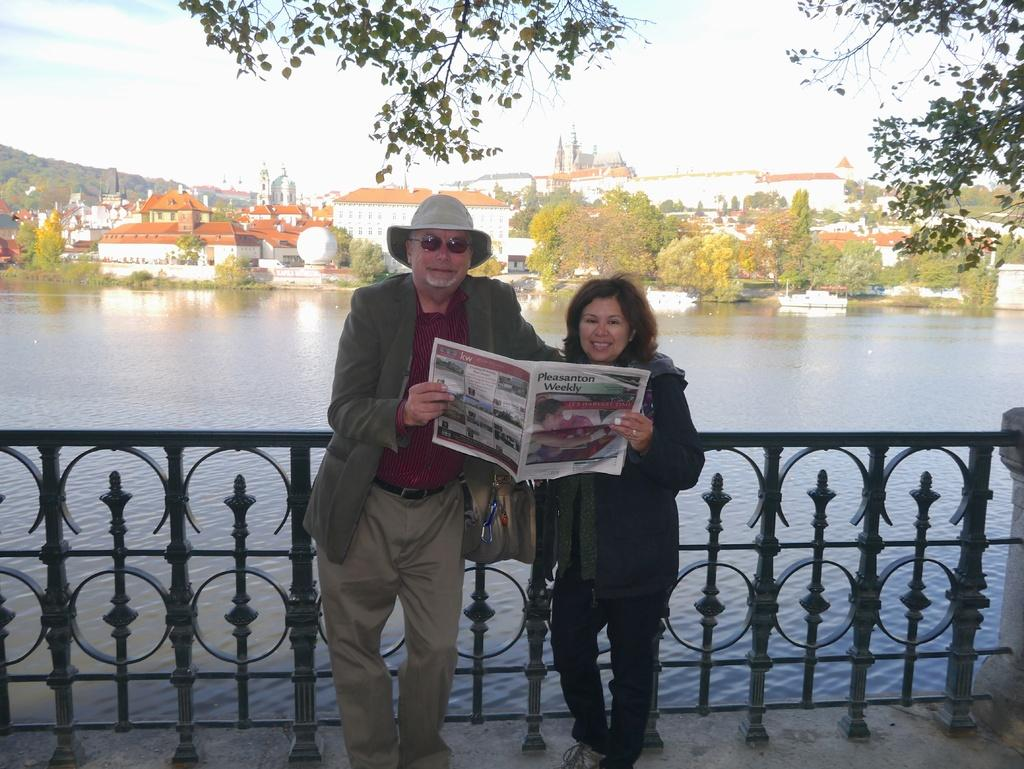How many people are present in the image? There are two persons in the image. What object can be seen near the people? There is a newspaper in the image. What type of fencing is present in the image? There is iron fencing in the image. What natural element is visible in the image? Water is visible in the image. What type of vehicles can be seen in the image? There are boats in the image. What type of structures are present in the image? There are buildings in the image. What type of vegetation is present in the image? There are trees in the image. What is visible in the background of the image? The sky is visible in the background of the image. What is the name of the road that runs through the image? There is no road present in the image, so it is not possible to determine the name of a road. 